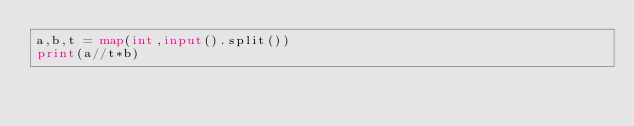Convert code to text. <code><loc_0><loc_0><loc_500><loc_500><_Python_>a,b,t = map(int,input().split())
print(a//t*b)</code> 